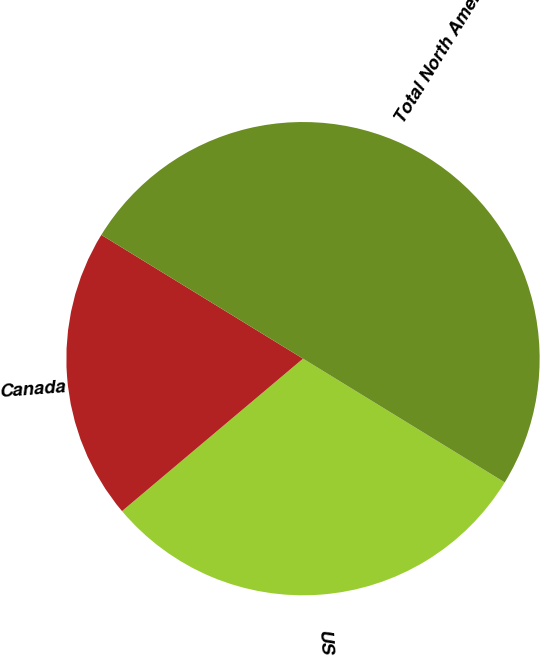Convert chart to OTSL. <chart><loc_0><loc_0><loc_500><loc_500><pie_chart><fcel>US<fcel>Canada<fcel>Total North America<nl><fcel>30.1%<fcel>19.9%<fcel>50.0%<nl></chart> 